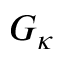<formula> <loc_0><loc_0><loc_500><loc_500>G _ { \kappa }</formula> 